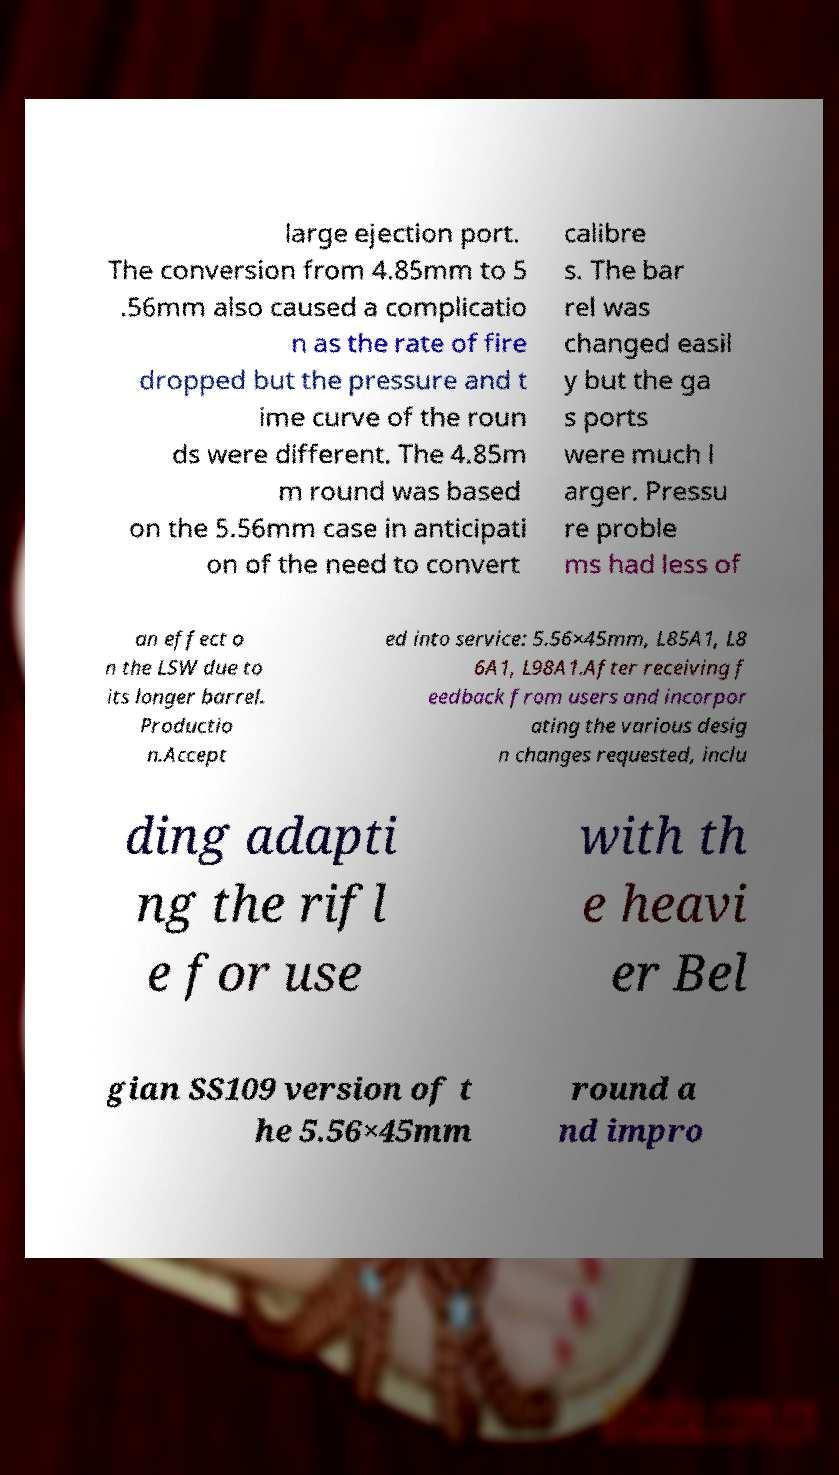There's text embedded in this image that I need extracted. Can you transcribe it verbatim? large ejection port. The conversion from 4.85mm to 5 .56mm also caused a complicatio n as the rate of fire dropped but the pressure and t ime curve of the roun ds were different. The 4.85m m round was based on the 5.56mm case in anticipati on of the need to convert calibre s. The bar rel was changed easil y but the ga s ports were much l arger. Pressu re proble ms had less of an effect o n the LSW due to its longer barrel. Productio n.Accept ed into service: 5.56×45mm, L85A1, L8 6A1, L98A1.After receiving f eedback from users and incorpor ating the various desig n changes requested, inclu ding adapti ng the rifl e for use with th e heavi er Bel gian SS109 version of t he 5.56×45mm round a nd impro 